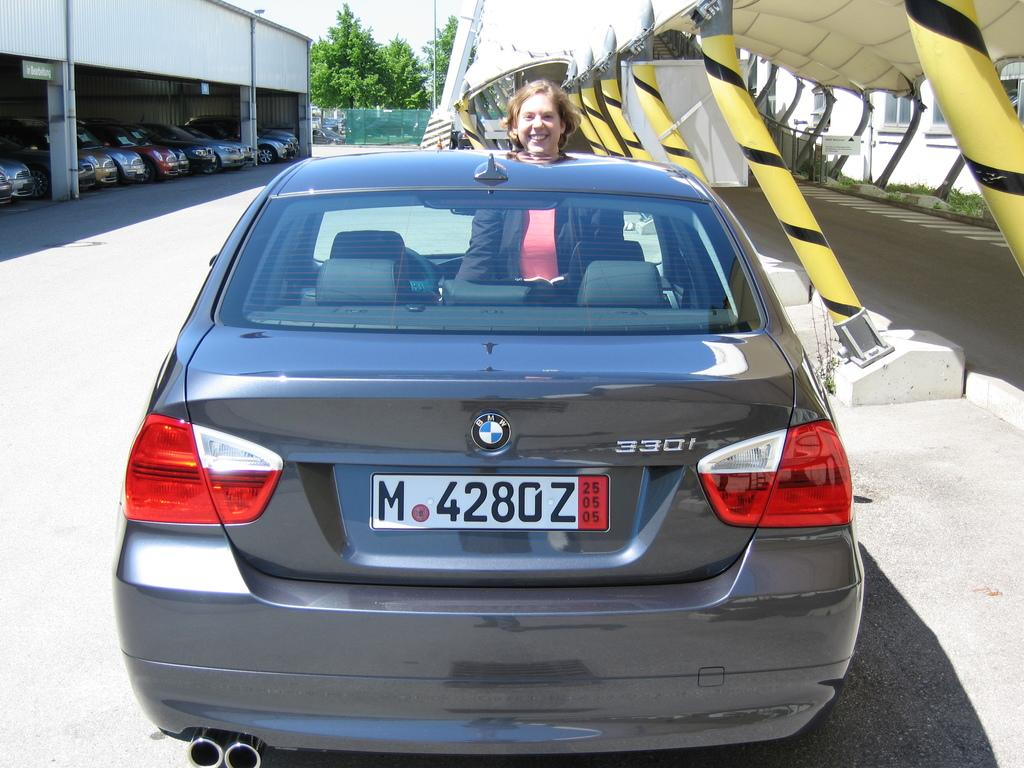What is the main subject of the image? There is a person in a car in the image. What else can be seen in the image besides the person in the car? There are vehicles in a shed on the left side of the image, and trees are visible in the background. Where is the brush located in the image? There is no brush present in the image. What type of hydrant can be seen near the car in the image? There is no hydrant present in the image. 